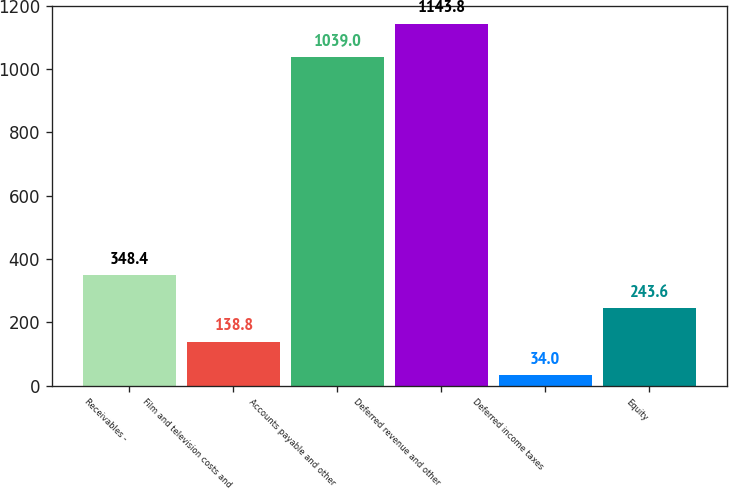<chart> <loc_0><loc_0><loc_500><loc_500><bar_chart><fcel>Receivables -<fcel>Film and television costs and<fcel>Accounts payable and other<fcel>Deferred revenue and other<fcel>Deferred income taxes<fcel>Equity<nl><fcel>348.4<fcel>138.8<fcel>1039<fcel>1143.8<fcel>34<fcel>243.6<nl></chart> 